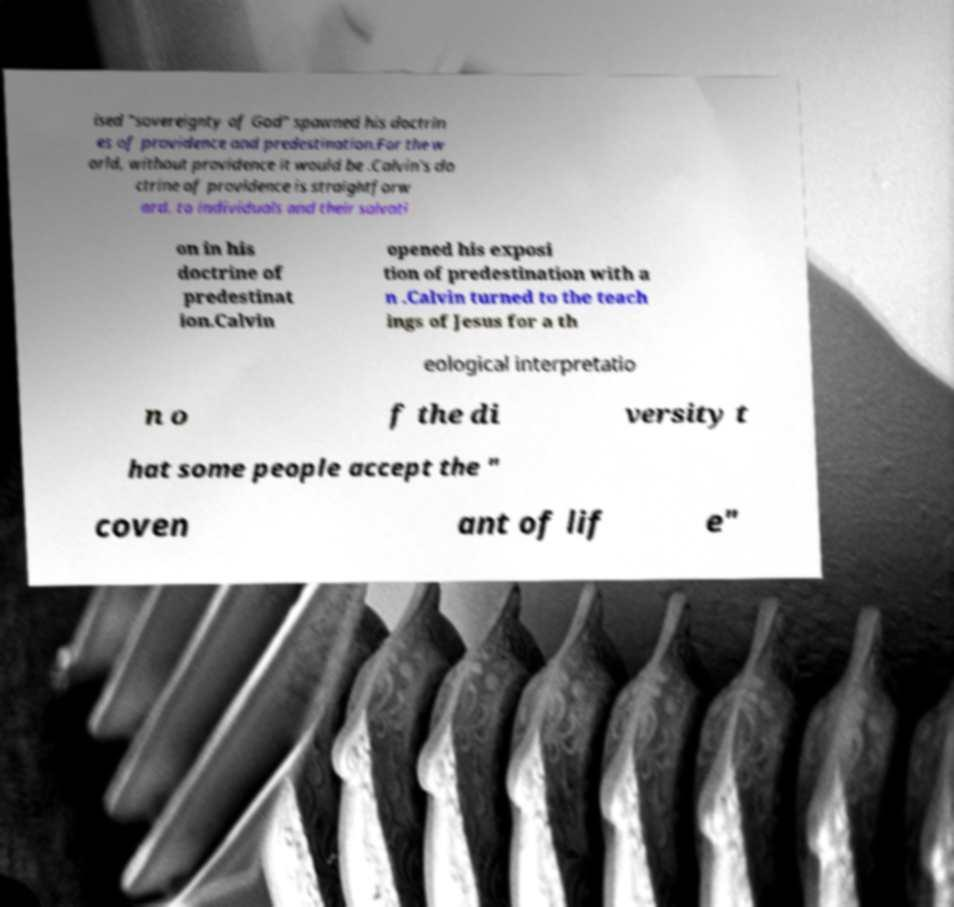Please read and relay the text visible in this image. What does it say? ised "sovereignty of God" spawned his doctrin es of providence and predestination.For the w orld, without providence it would be .Calvin's do ctrine of providence is straightforw ard. to individuals and their salvati on in his doctrine of predestinat ion.Calvin opened his exposi tion of predestination with a n .Calvin turned to the teach ings of Jesus for a th eological interpretatio n o f the di versity t hat some people accept the " coven ant of lif e" 